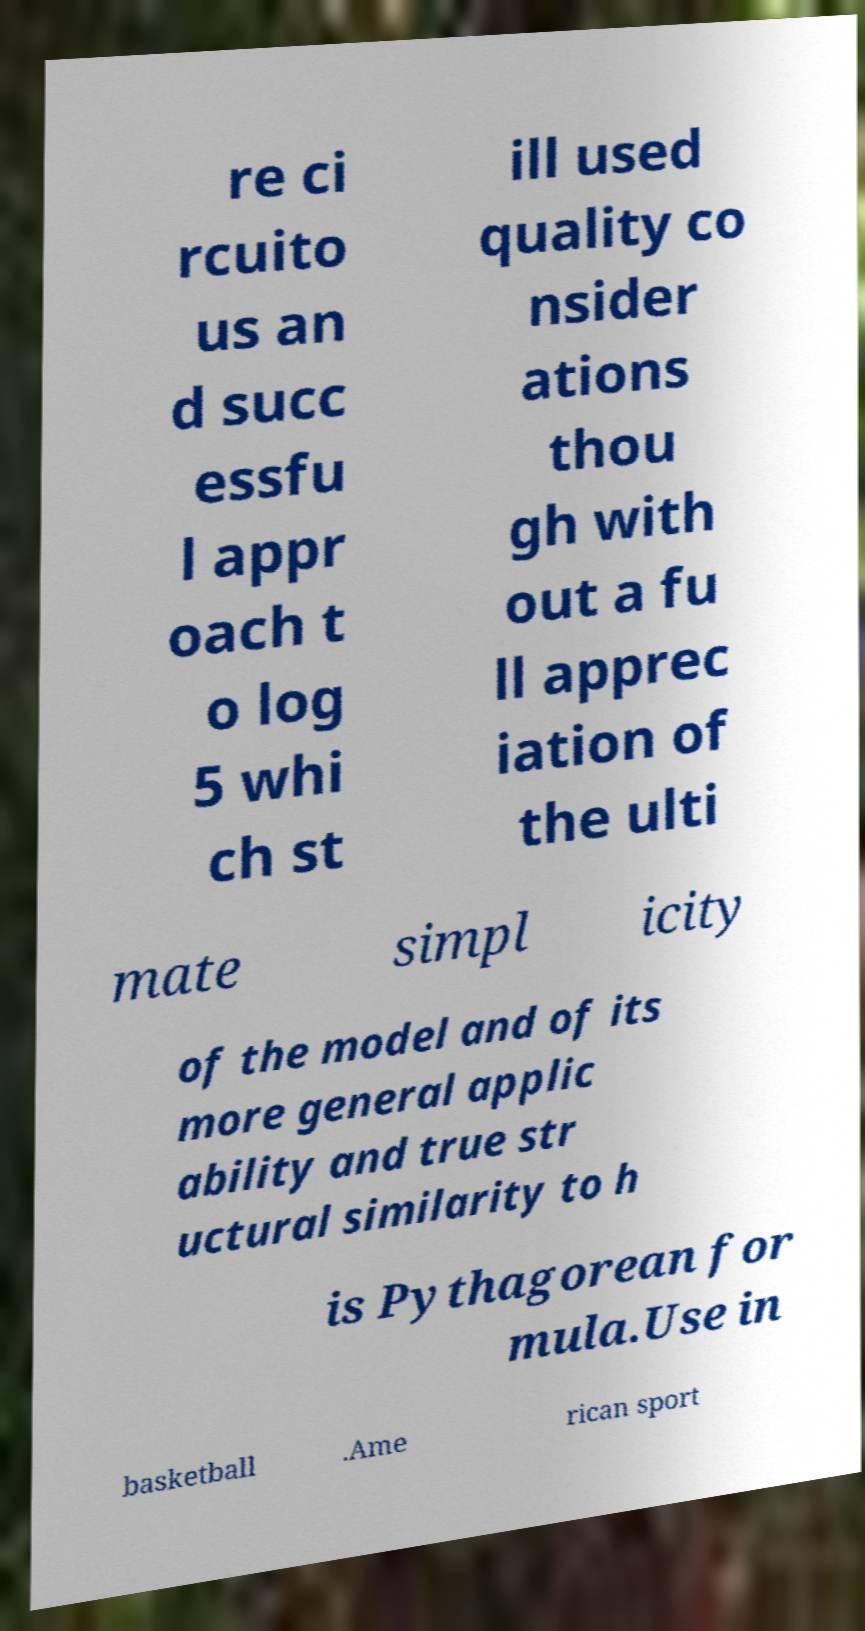What messages or text are displayed in this image? I need them in a readable, typed format. re ci rcuito us an d succ essfu l appr oach t o log 5 whi ch st ill used quality co nsider ations thou gh with out a fu ll apprec iation of the ulti mate simpl icity of the model and of its more general applic ability and true str uctural similarity to h is Pythagorean for mula.Use in basketball .Ame rican sport 